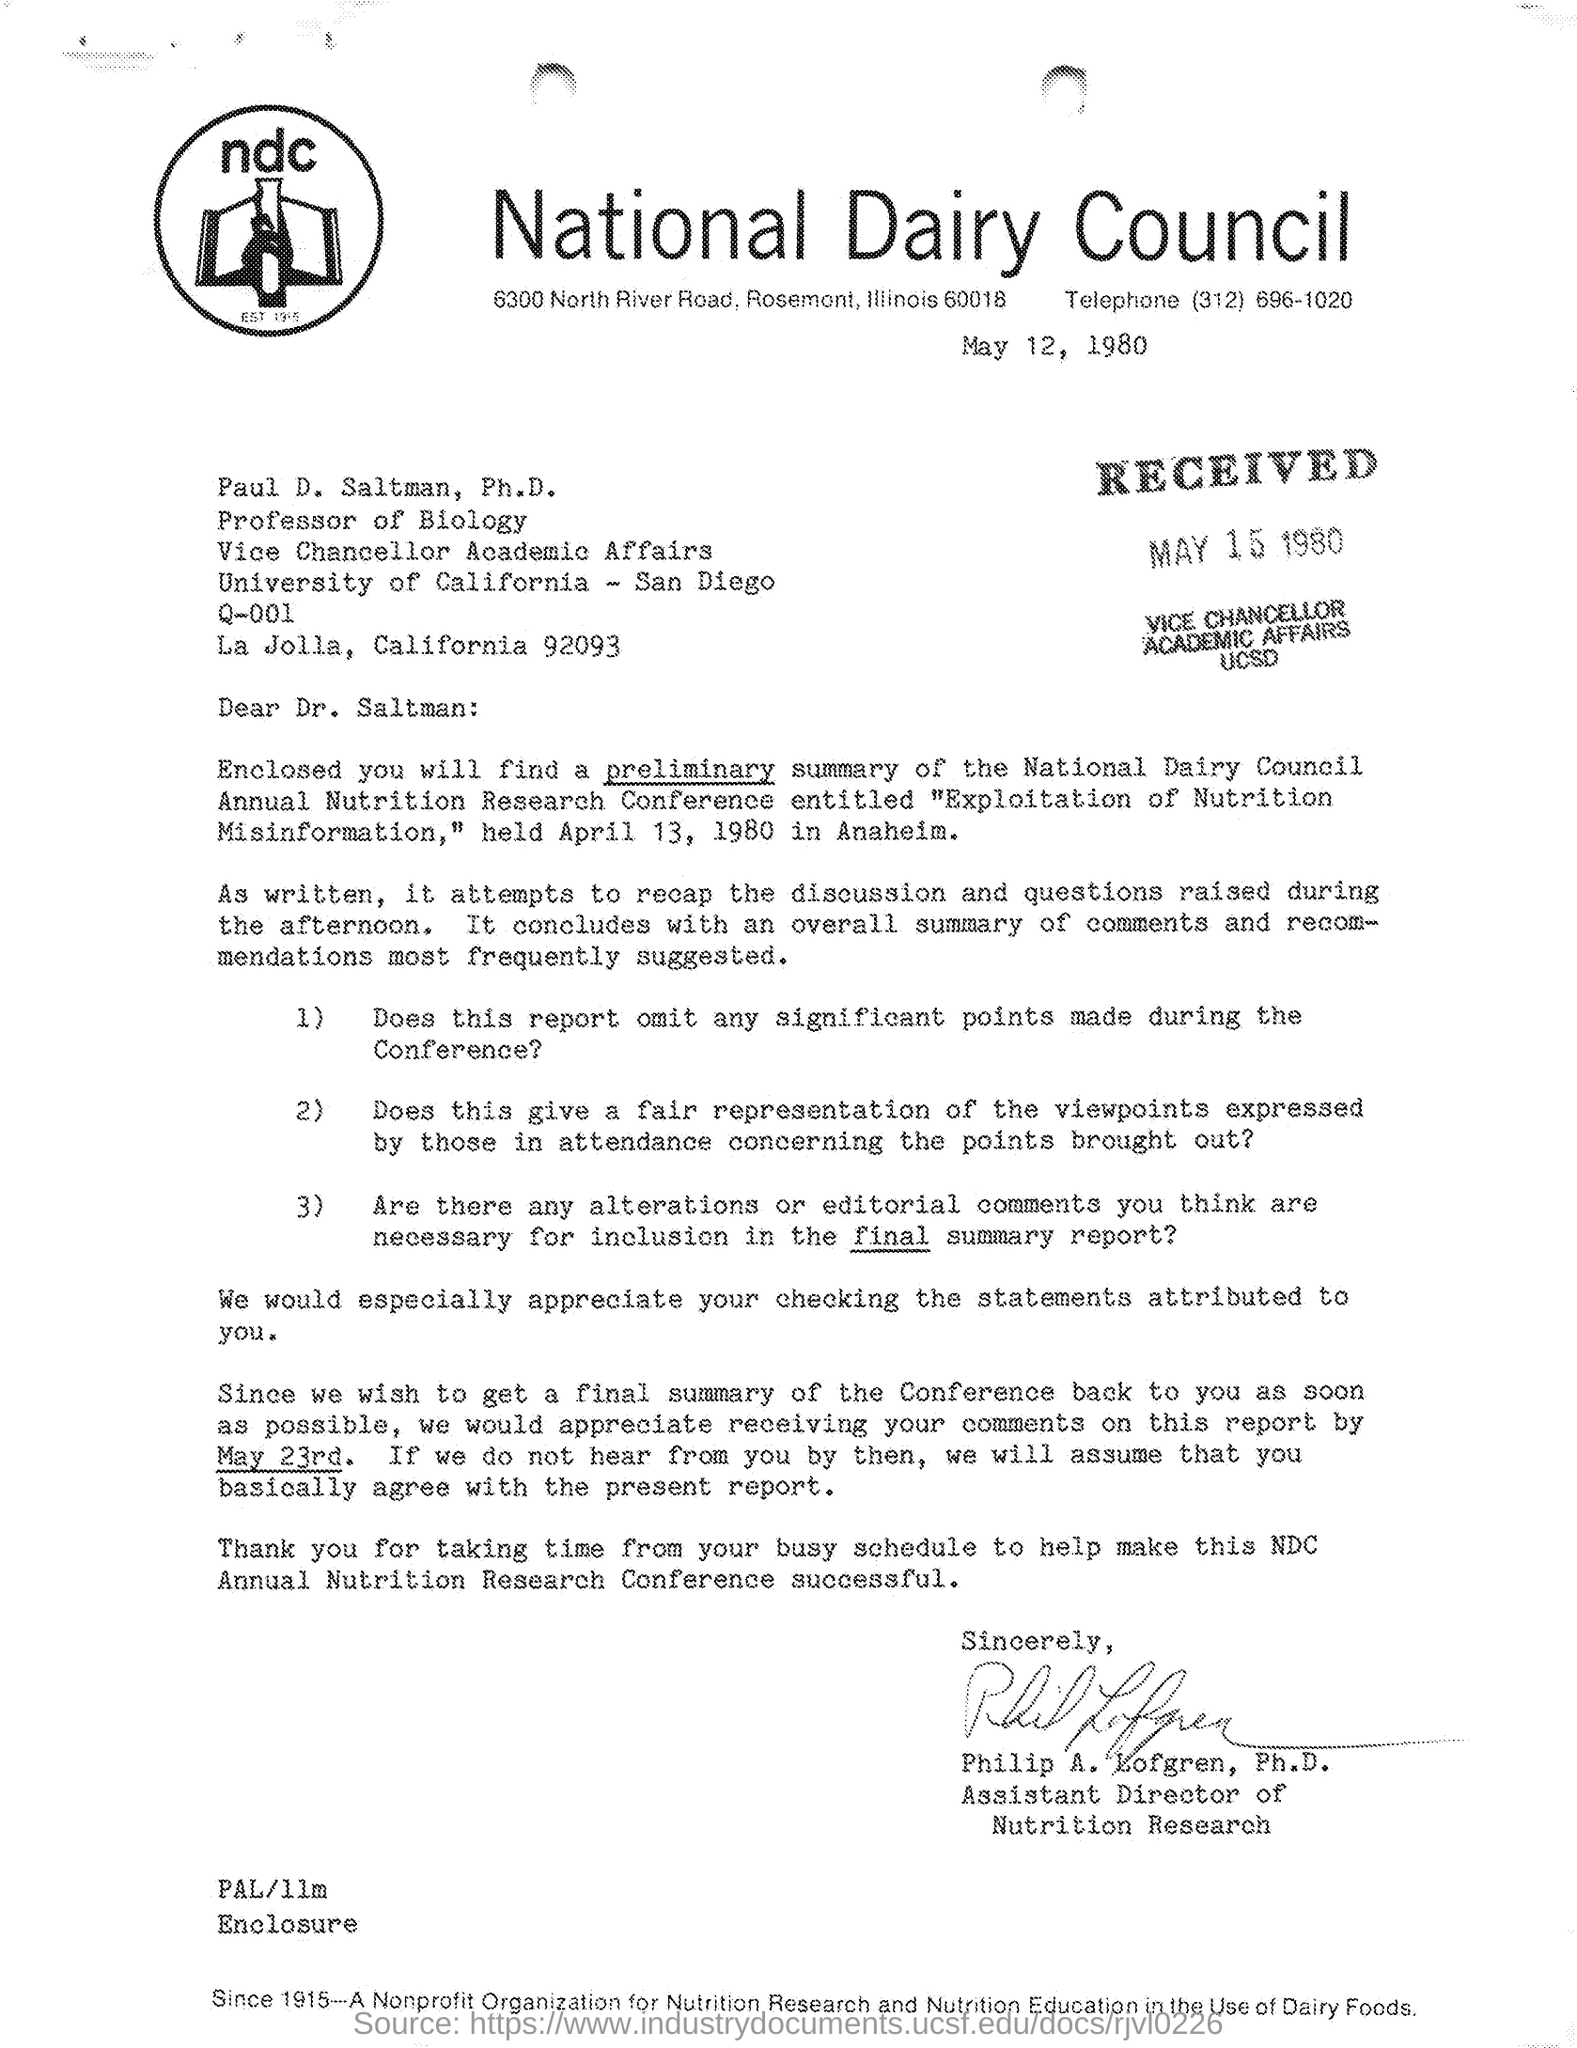Which organization's  name is in the letter head?
Give a very brief answer. National Dairy Council. What is the received date of this letter?
Your response must be concise. MAY 15 1980. Who is the addressee of this letter?
Offer a very short reply. Paul D. Saltman, Ph.D. , Dr. Saltman:. Who has signed this letter?
Your response must be concise. Assistant Director of Nutrition Research. What is the designation of Philip A. Lofgren, Ph.D.?
Ensure brevity in your answer.  ASSISTANT DIRECTOR. What is the issued date of the letter?
Your response must be concise. May 12, 1980. Who is the Vice Chancellor Academic Aaffairs, University of California - San Diego?
Ensure brevity in your answer.  PAUL D. SALTMAN. 